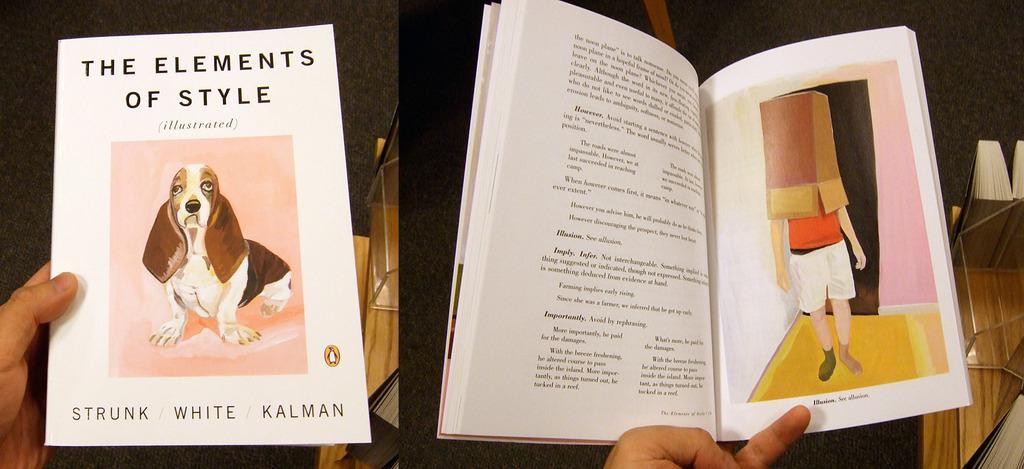How would you summarize this image in a sentence or two? In this image we can collage of two pictures where we can see the person's hands holding the books, we can see cover page of a book and an open book with some image and text. 